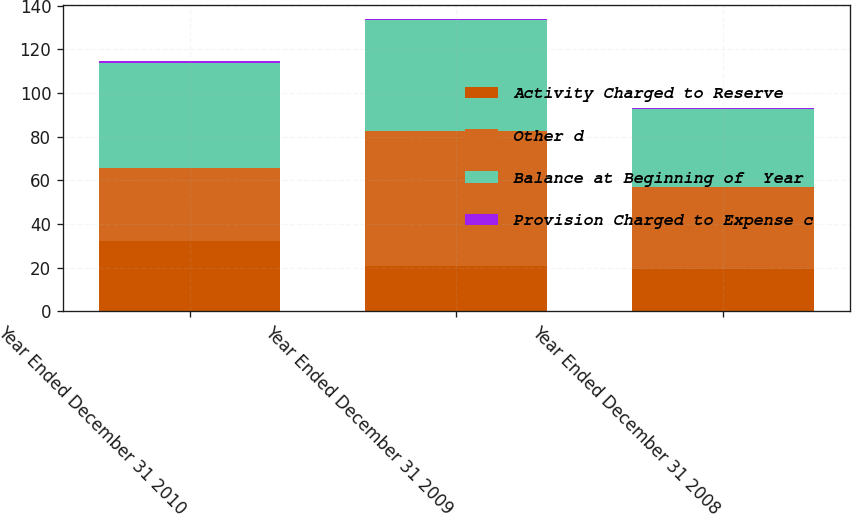<chart> <loc_0><loc_0><loc_500><loc_500><stacked_bar_chart><ecel><fcel>Year Ended December 31 2010<fcel>Year Ended December 31 2009<fcel>Year Ended December 31 2008<nl><fcel>Activity Charged to Reserve<fcel>32.2<fcel>20.8<fcel>19.4<nl><fcel>Other d<fcel>33.6<fcel>61.8<fcel>37.5<nl><fcel>Balance at Beginning of  Year<fcel>47.9<fcel>50.8<fcel>35.6<nl><fcel>Provision Charged to Expense c<fcel>1.1<fcel>0.4<fcel>0.5<nl></chart> 